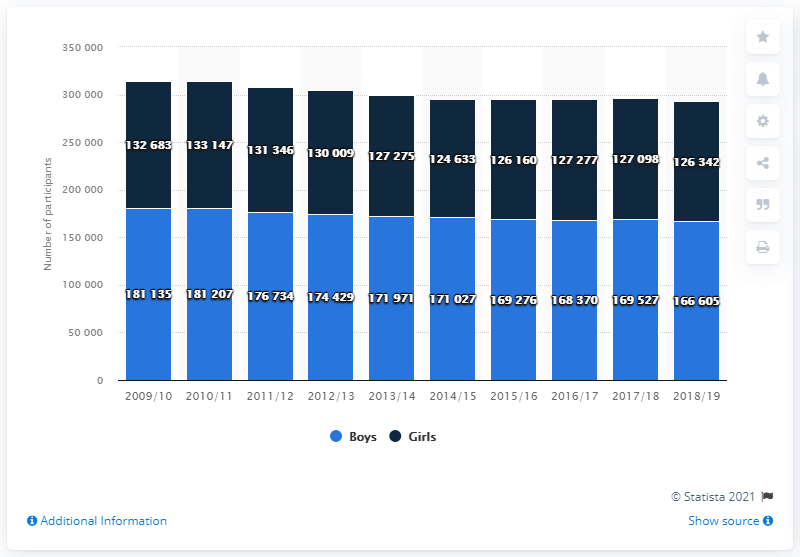Draw attention to some important aspects in this diagram. The sum of the highest and lowest values of a light blue bar is 34,7740. The value of the highest dark blue bar is 132683. In the academic year 2018/19, a total of 166,605 boys participated in high school sports. 